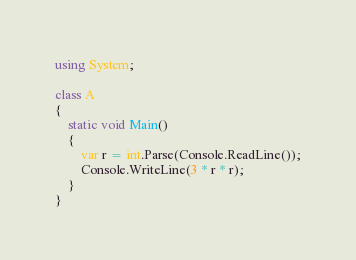Convert code to text. <code><loc_0><loc_0><loc_500><loc_500><_C#_>using System;

class A
{
    static void Main()
    {
        var r = int.Parse(Console.ReadLine());
        Console.WriteLine(3 * r * r);
    }
}
</code> 